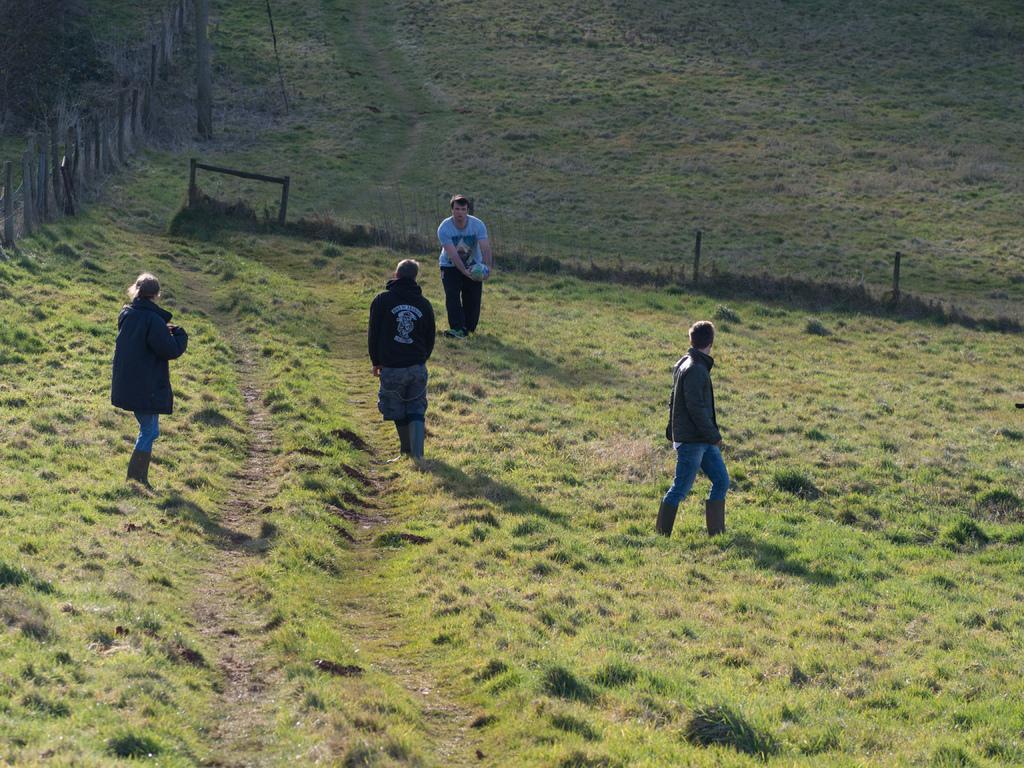Please provide a concise description of this image. In this image we can see the people. We can also see a man holding the ball. In the background we can see the grass. We can also see the fence and also the wooden poles. 